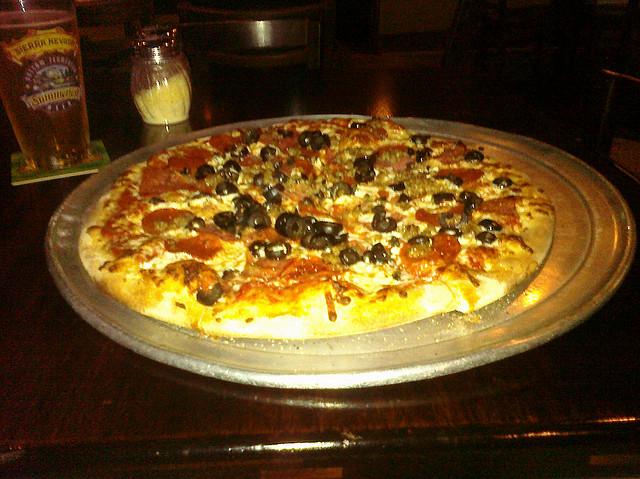What is the pizza for?
Be succinct. Dinner. How many slices are there?
Be succinct. 8. Are there olives on the pizza?
Keep it brief. Yes. 